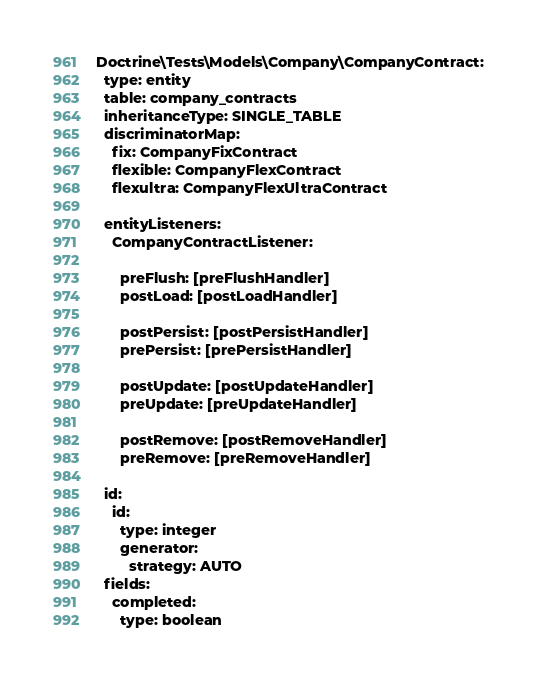<code> <loc_0><loc_0><loc_500><loc_500><_YAML_>Doctrine\Tests\Models\Company\CompanyContract:
  type: entity
  table: company_contracts
  inheritanceType: SINGLE_TABLE
  discriminatorMap:
    fix: CompanyFixContract
    flexible: CompanyFlexContract
    flexultra: CompanyFlexUltraContract

  entityListeners:
    CompanyContractListener:

      preFlush: [preFlushHandler]
      postLoad: [postLoadHandler]

      postPersist: [postPersistHandler]
      prePersist: [prePersistHandler]

      postUpdate: [postUpdateHandler]
      preUpdate: [preUpdateHandler]

      postRemove: [postRemoveHandler]
      preRemove: [preRemoveHandler]

  id:
    id:
      type: integer
      generator:
        strategy: AUTO
  fields:
    completed:
      type: boolean</code> 